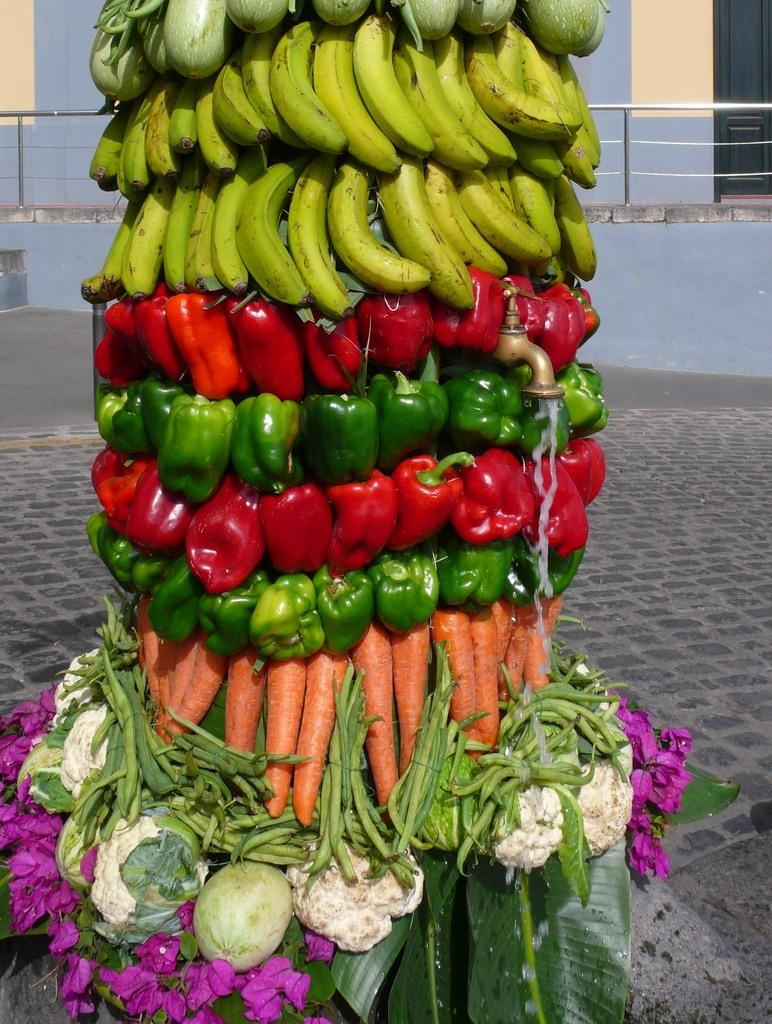What type of plants can be seen in the image? There are flowers, leaves, carrots, capsicums, bananas, and cauliflowers in the image. What is the purpose of the tap in the image? The tap's purpose is not specified in the image, but it is likely used for watering the plants or cleaning. What can be seen in the background of the image? There is a floor and a fence visible in the background of the image. Can you tell me how many toes the rat has in the image? There is no rat present in the image, so it is not possible to determine the number of toes it might have. 